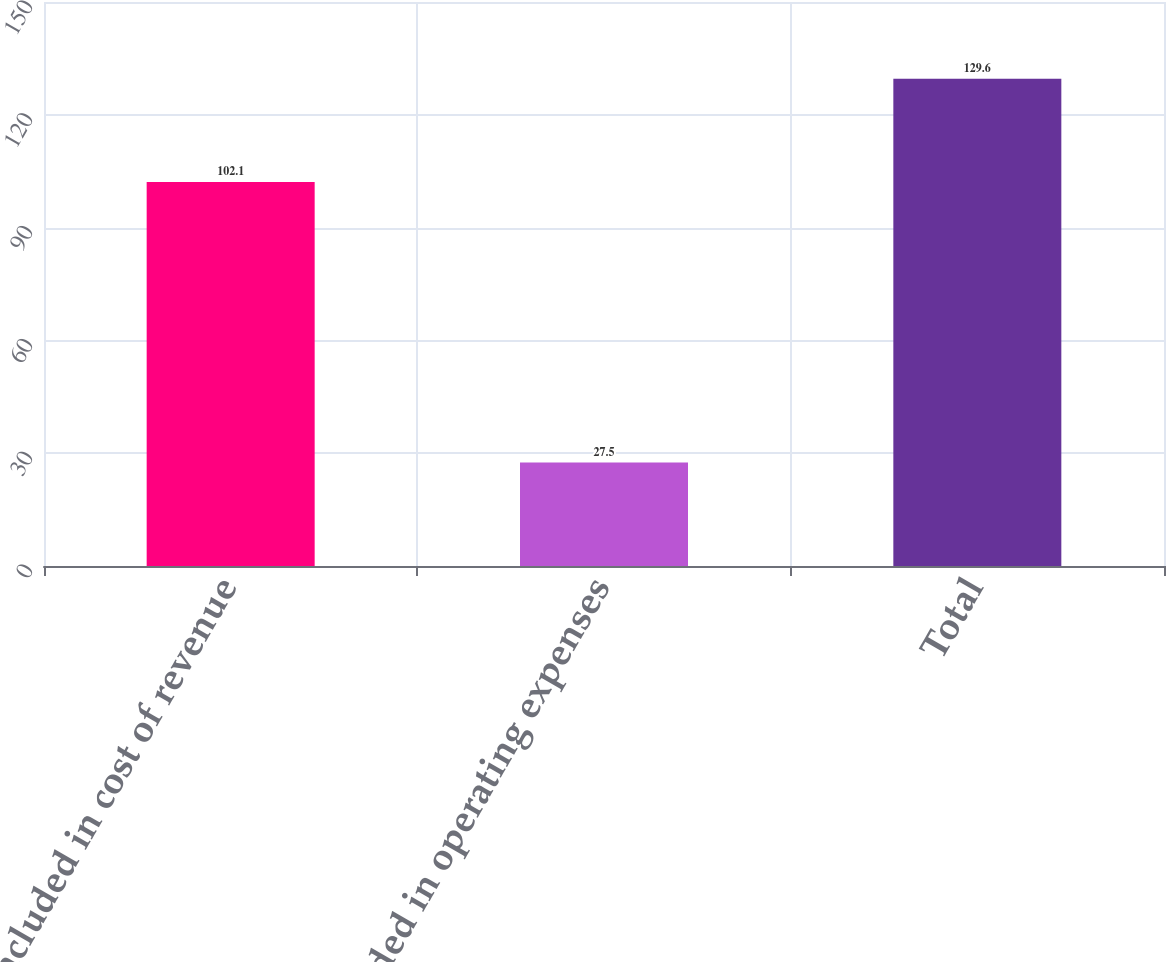Convert chart to OTSL. <chart><loc_0><loc_0><loc_500><loc_500><bar_chart><fcel>Included in cost of revenue<fcel>Included in operating expenses<fcel>Total<nl><fcel>102.1<fcel>27.5<fcel>129.6<nl></chart> 